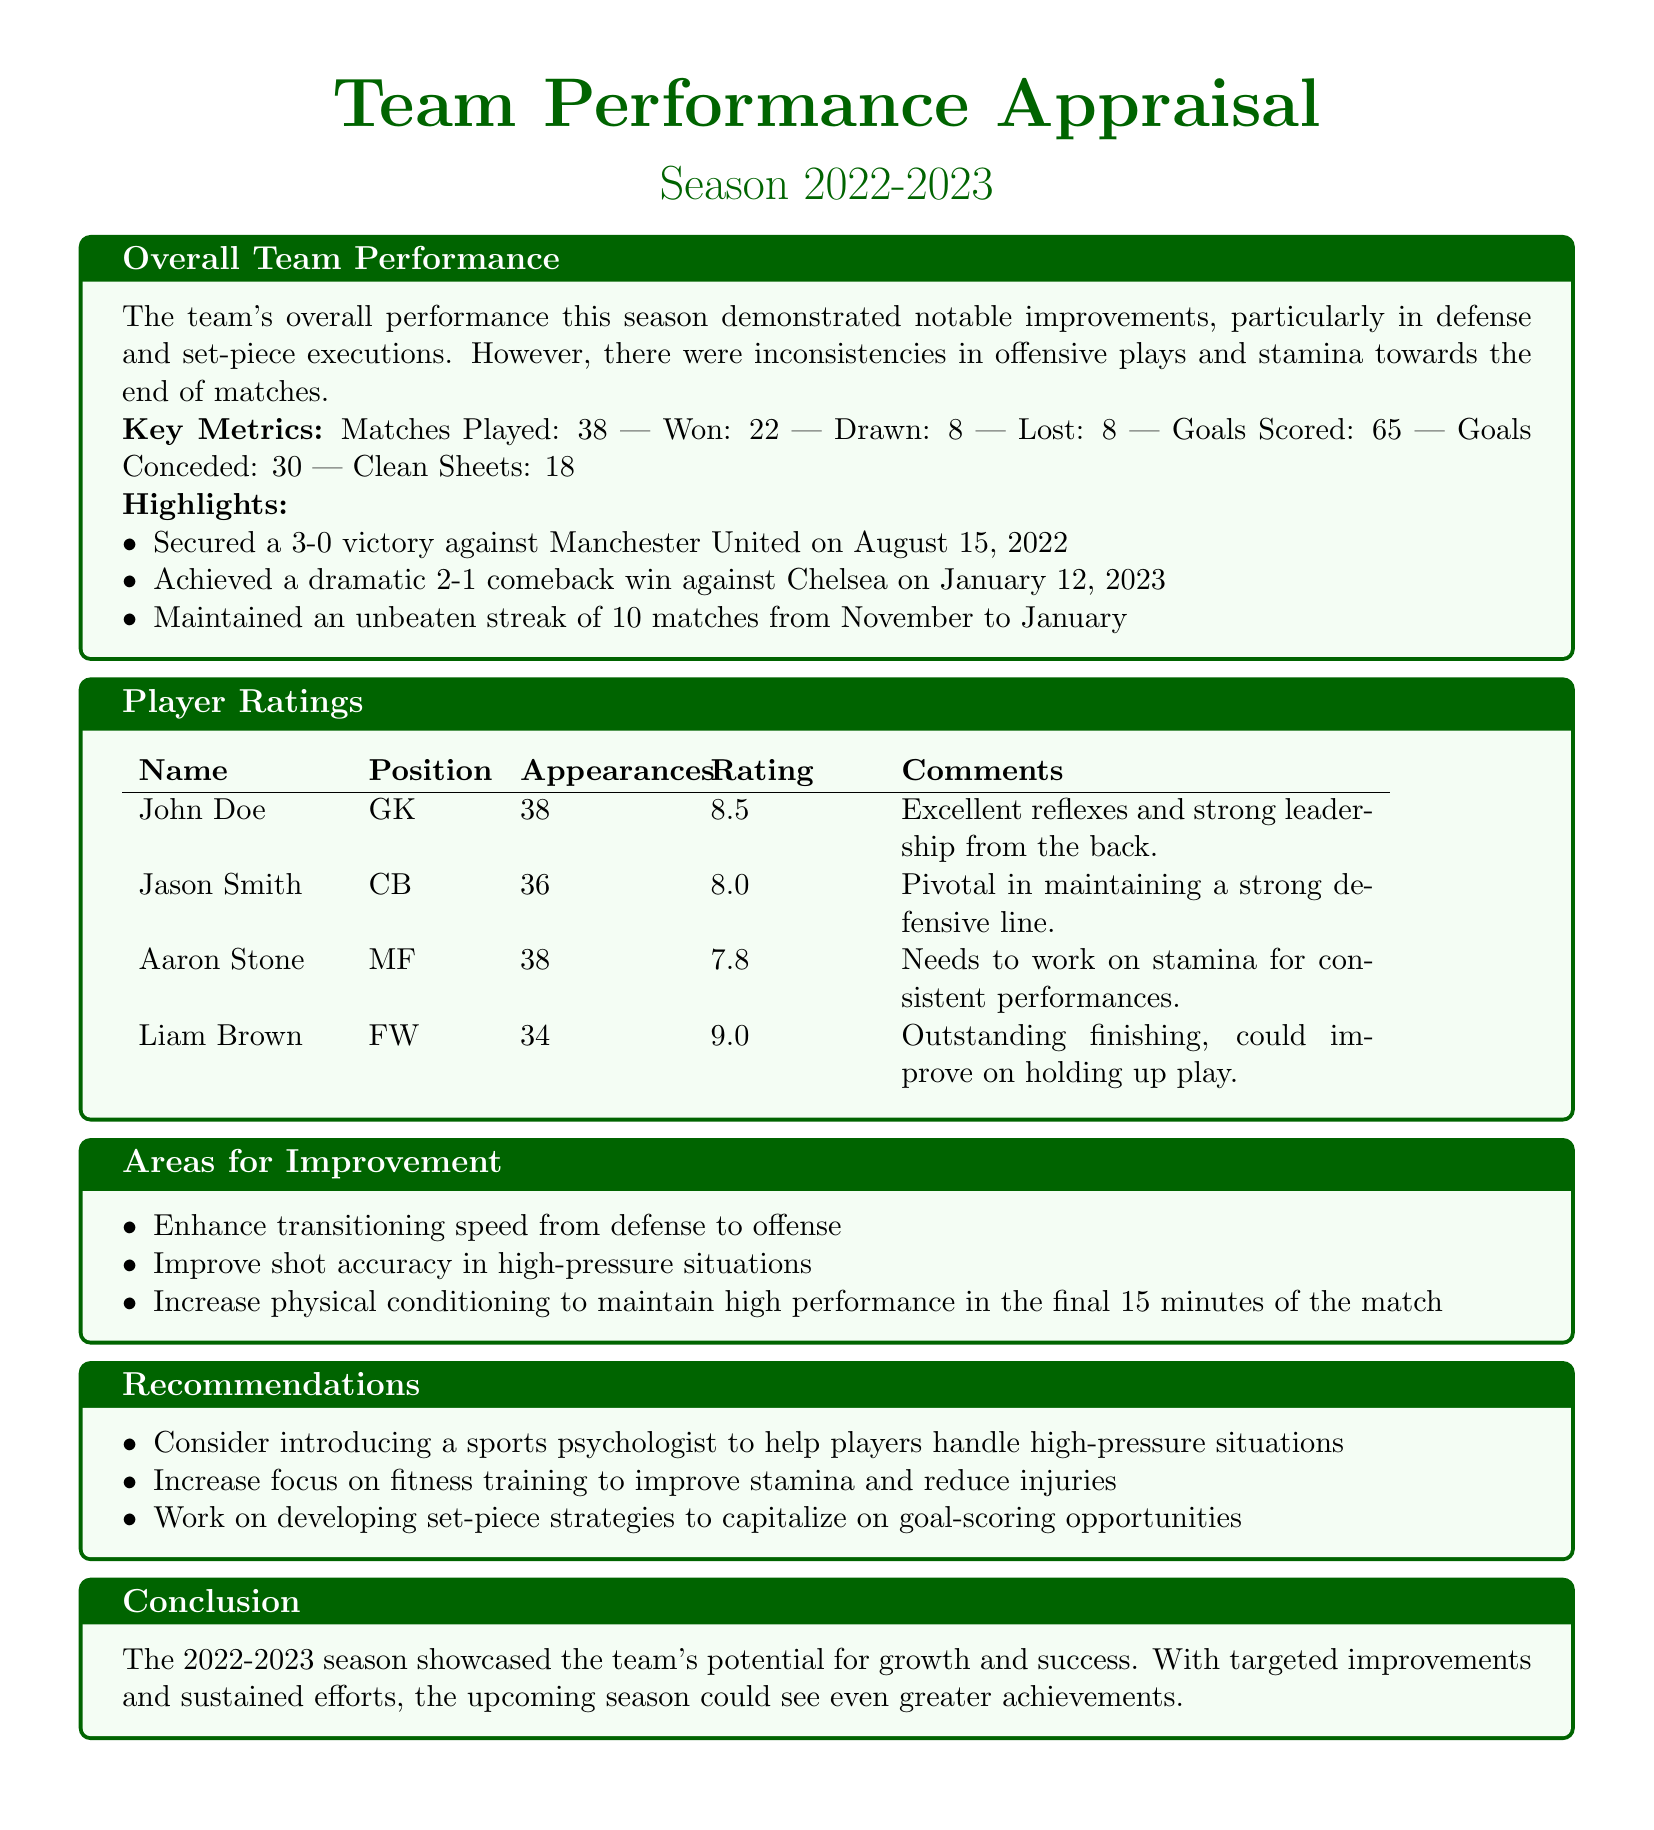What is the team's overall record for matches played? The overall record can be found in the key metrics section, which shows the team played a total of 38 matches.
Answer: 38 What was the highest player rating? The player ratings table indicates that the highest rating is for Liam Brown, who received a rating of 9.0.
Answer: 9.0 Which match resulted in a 3-0 victory? The highlight section mentions that the team secured a 3-0 victory against Manchester United on August 15, 2022.
Answer: Manchester United What area does Aaron Stone need to improve? The comments in the player ratings for Aaron Stone state that he needs to work on stamina for consistent performances.
Answer: Stamina How many goals did the team concede throughout the season? The key metrics show that the team conceded a total of 30 goals during the season.
Answer: 30 What is the total number of clean sheets achieved? The metrics highlight that the team maintained 18 clean sheets throughout the season.
Answer: 18 What does the appraisal suggest introducing to help players handle pressure? The recommendations section suggests considering the introduction of a sports psychologist to help players handle high-pressure situations.
Answer: Sports psychologist Which skill area should be enhanced according to the improvement section? One of the areas for improvement mentions enhancing transitioning speed from defense to offense.
Answer: Transitioning speed 